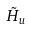Convert formula to latex. <formula><loc_0><loc_0><loc_500><loc_500>\tilde { H } _ { u }</formula> 